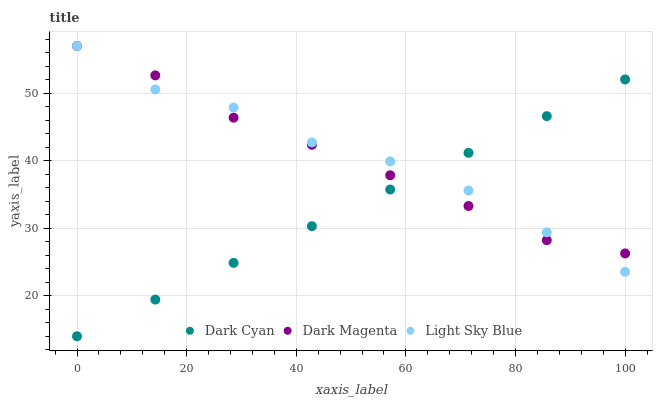Does Dark Cyan have the minimum area under the curve?
Answer yes or no. Yes. Does Light Sky Blue have the maximum area under the curve?
Answer yes or no. Yes. Does Dark Magenta have the minimum area under the curve?
Answer yes or no. No. Does Dark Magenta have the maximum area under the curve?
Answer yes or no. No. Is Dark Cyan the smoothest?
Answer yes or no. Yes. Is Light Sky Blue the roughest?
Answer yes or no. Yes. Is Dark Magenta the smoothest?
Answer yes or no. No. Is Dark Magenta the roughest?
Answer yes or no. No. Does Dark Cyan have the lowest value?
Answer yes or no. Yes. Does Light Sky Blue have the lowest value?
Answer yes or no. No. Does Dark Magenta have the highest value?
Answer yes or no. Yes. Does Dark Magenta intersect Light Sky Blue?
Answer yes or no. Yes. Is Dark Magenta less than Light Sky Blue?
Answer yes or no. No. Is Dark Magenta greater than Light Sky Blue?
Answer yes or no. No. 